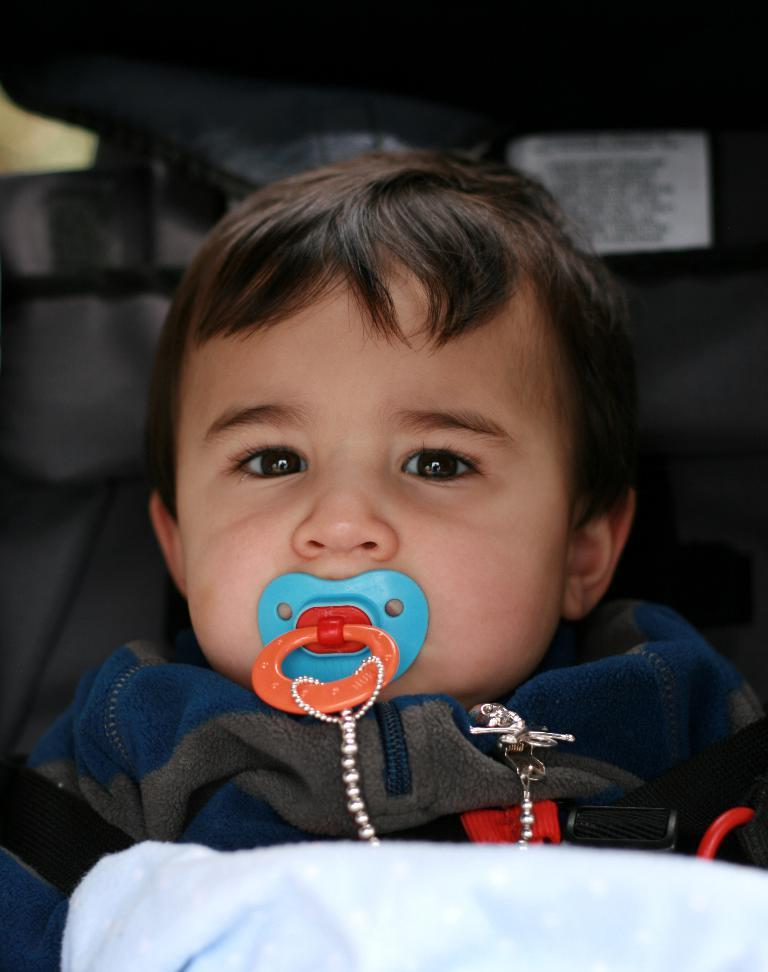What is the main subject of the image? There is a baby in the image. What is the baby's position in the image? The baby is laying down. What is the baby wearing? The baby is wearing a blue and gray dress. What is in the baby's mouth? There is an object in the baby's mouth. What colors can be seen on the object in the baby's mouth? The object has blue and red colors. Can you see any islands in the background of the image? There is no background visible in the image, and therefore no islands can be seen. 